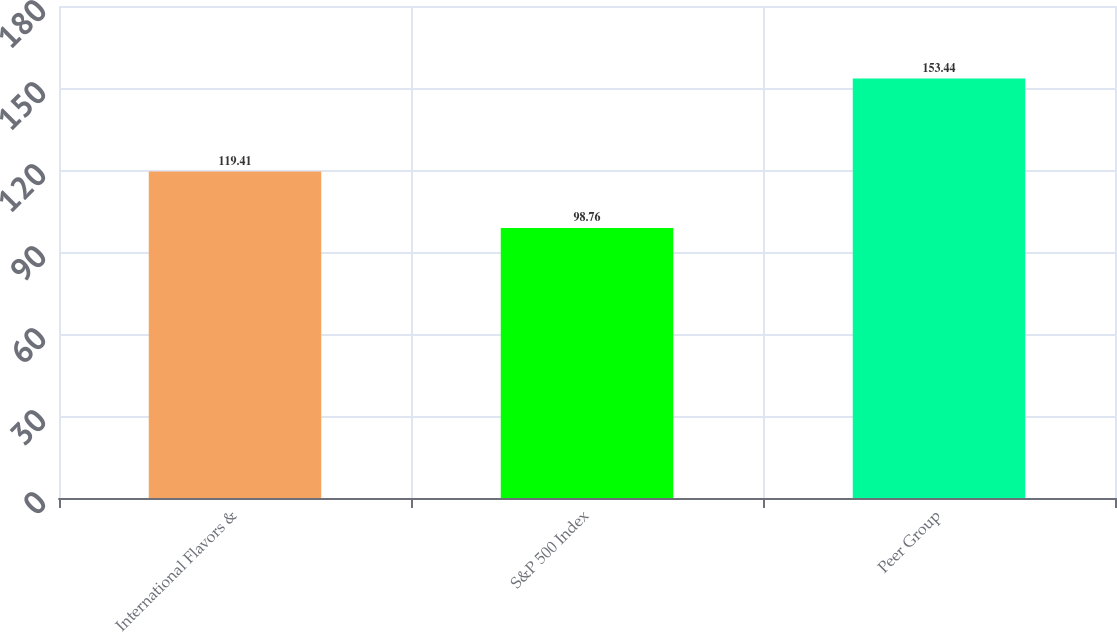Convert chart to OTSL. <chart><loc_0><loc_0><loc_500><loc_500><bar_chart><fcel>International Flavors &<fcel>S&P 500 Index<fcel>Peer Group<nl><fcel>119.41<fcel>98.76<fcel>153.44<nl></chart> 